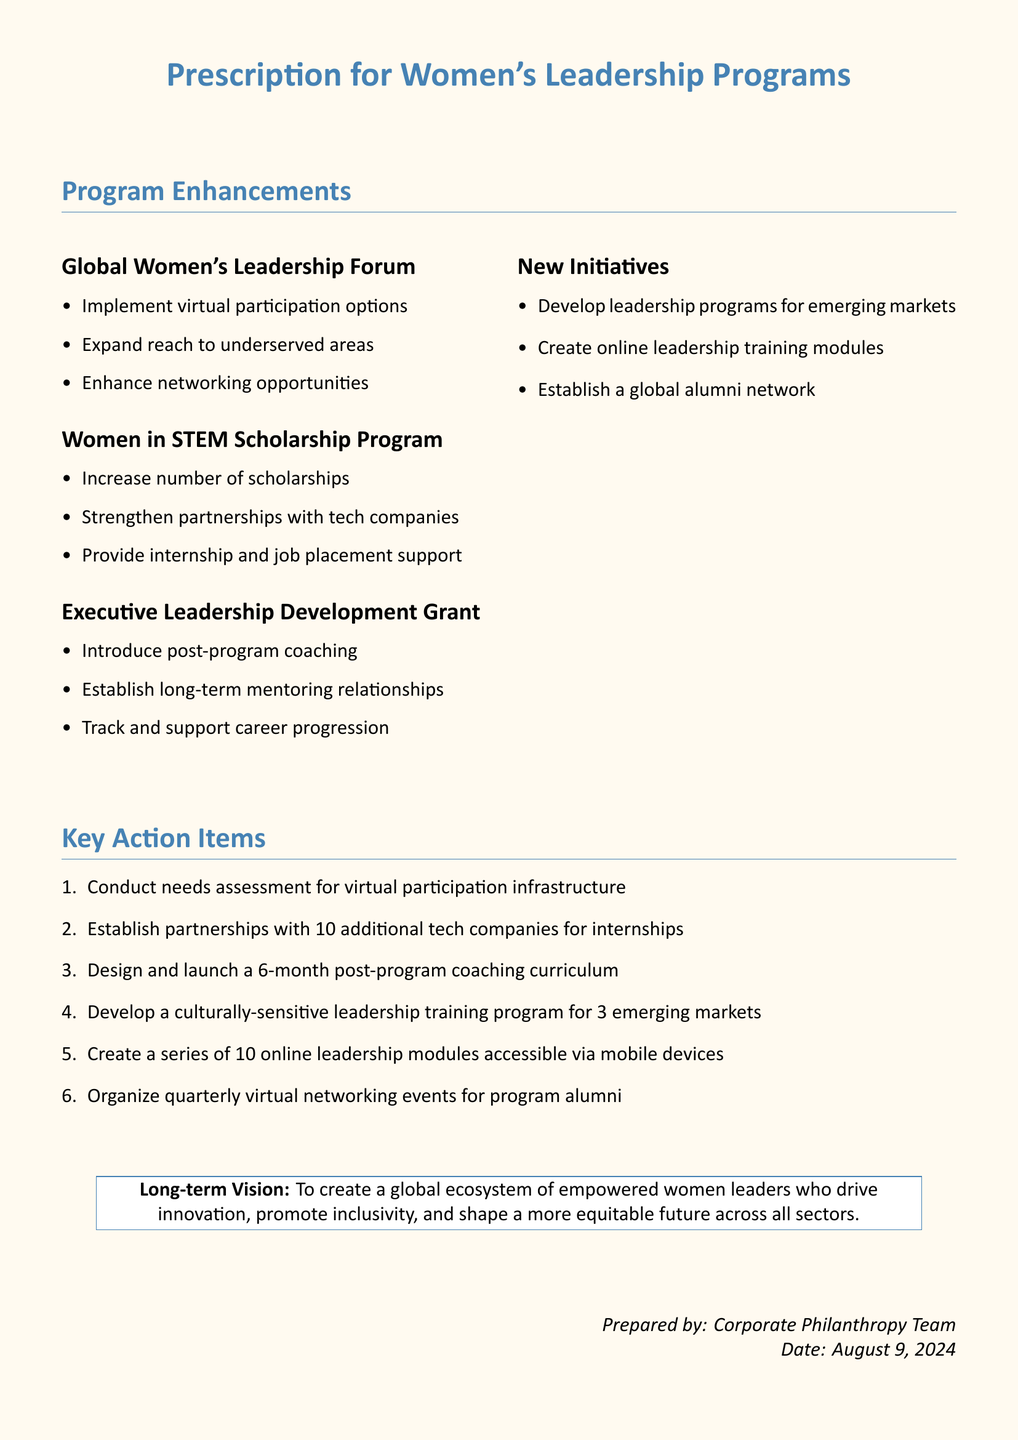What is the title of the document? The title of the document is prominently stated at the top, referring to the focus of the report.
Answer: Prescription for Women's Leadership Programs How many key action items are listed? The number of key action items is indicated as part of the enumerated list in the document.
Answer: 6 What is one enhancement of the Global Women's Leadership Forum? The specific enhancements for the Global Women's Leadership Forum are outlined in the document.
Answer: Implement virtual participation options What is the long-term vision stated in the document? The document includes a statement of long-term vision at the bottom, summarizing the goal of the programs.
Answer: To create a global ecosystem of empowered women leaders Which program aims to strengthen partnerships with tech companies? The specific program related to tech companies is mentioned in its enhancements section of the document.
Answer: Women in STEM Scholarship Program What type of initiative is proposed for emerging markets? The document discusses new initiatives targeting specific global regions.
Answer: Leadership programs for emerging markets 